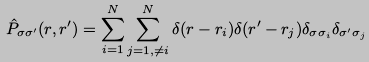Convert formula to latex. <formula><loc_0><loc_0><loc_500><loc_500>\hat { P } _ { \sigma \sigma ^ { \prime } } ( { r } , { r } ^ { \prime } ) = \sum _ { i = 1 } ^ { N } \sum _ { j = 1 , \neq i } ^ { N } \delta ( { r } - { r } _ { i } ) \delta ( { r } ^ { \prime } - { r } _ { j } ) \delta _ { \sigma \sigma _ { i } } \delta _ { \sigma ^ { \prime } \sigma _ { j } }</formula> 